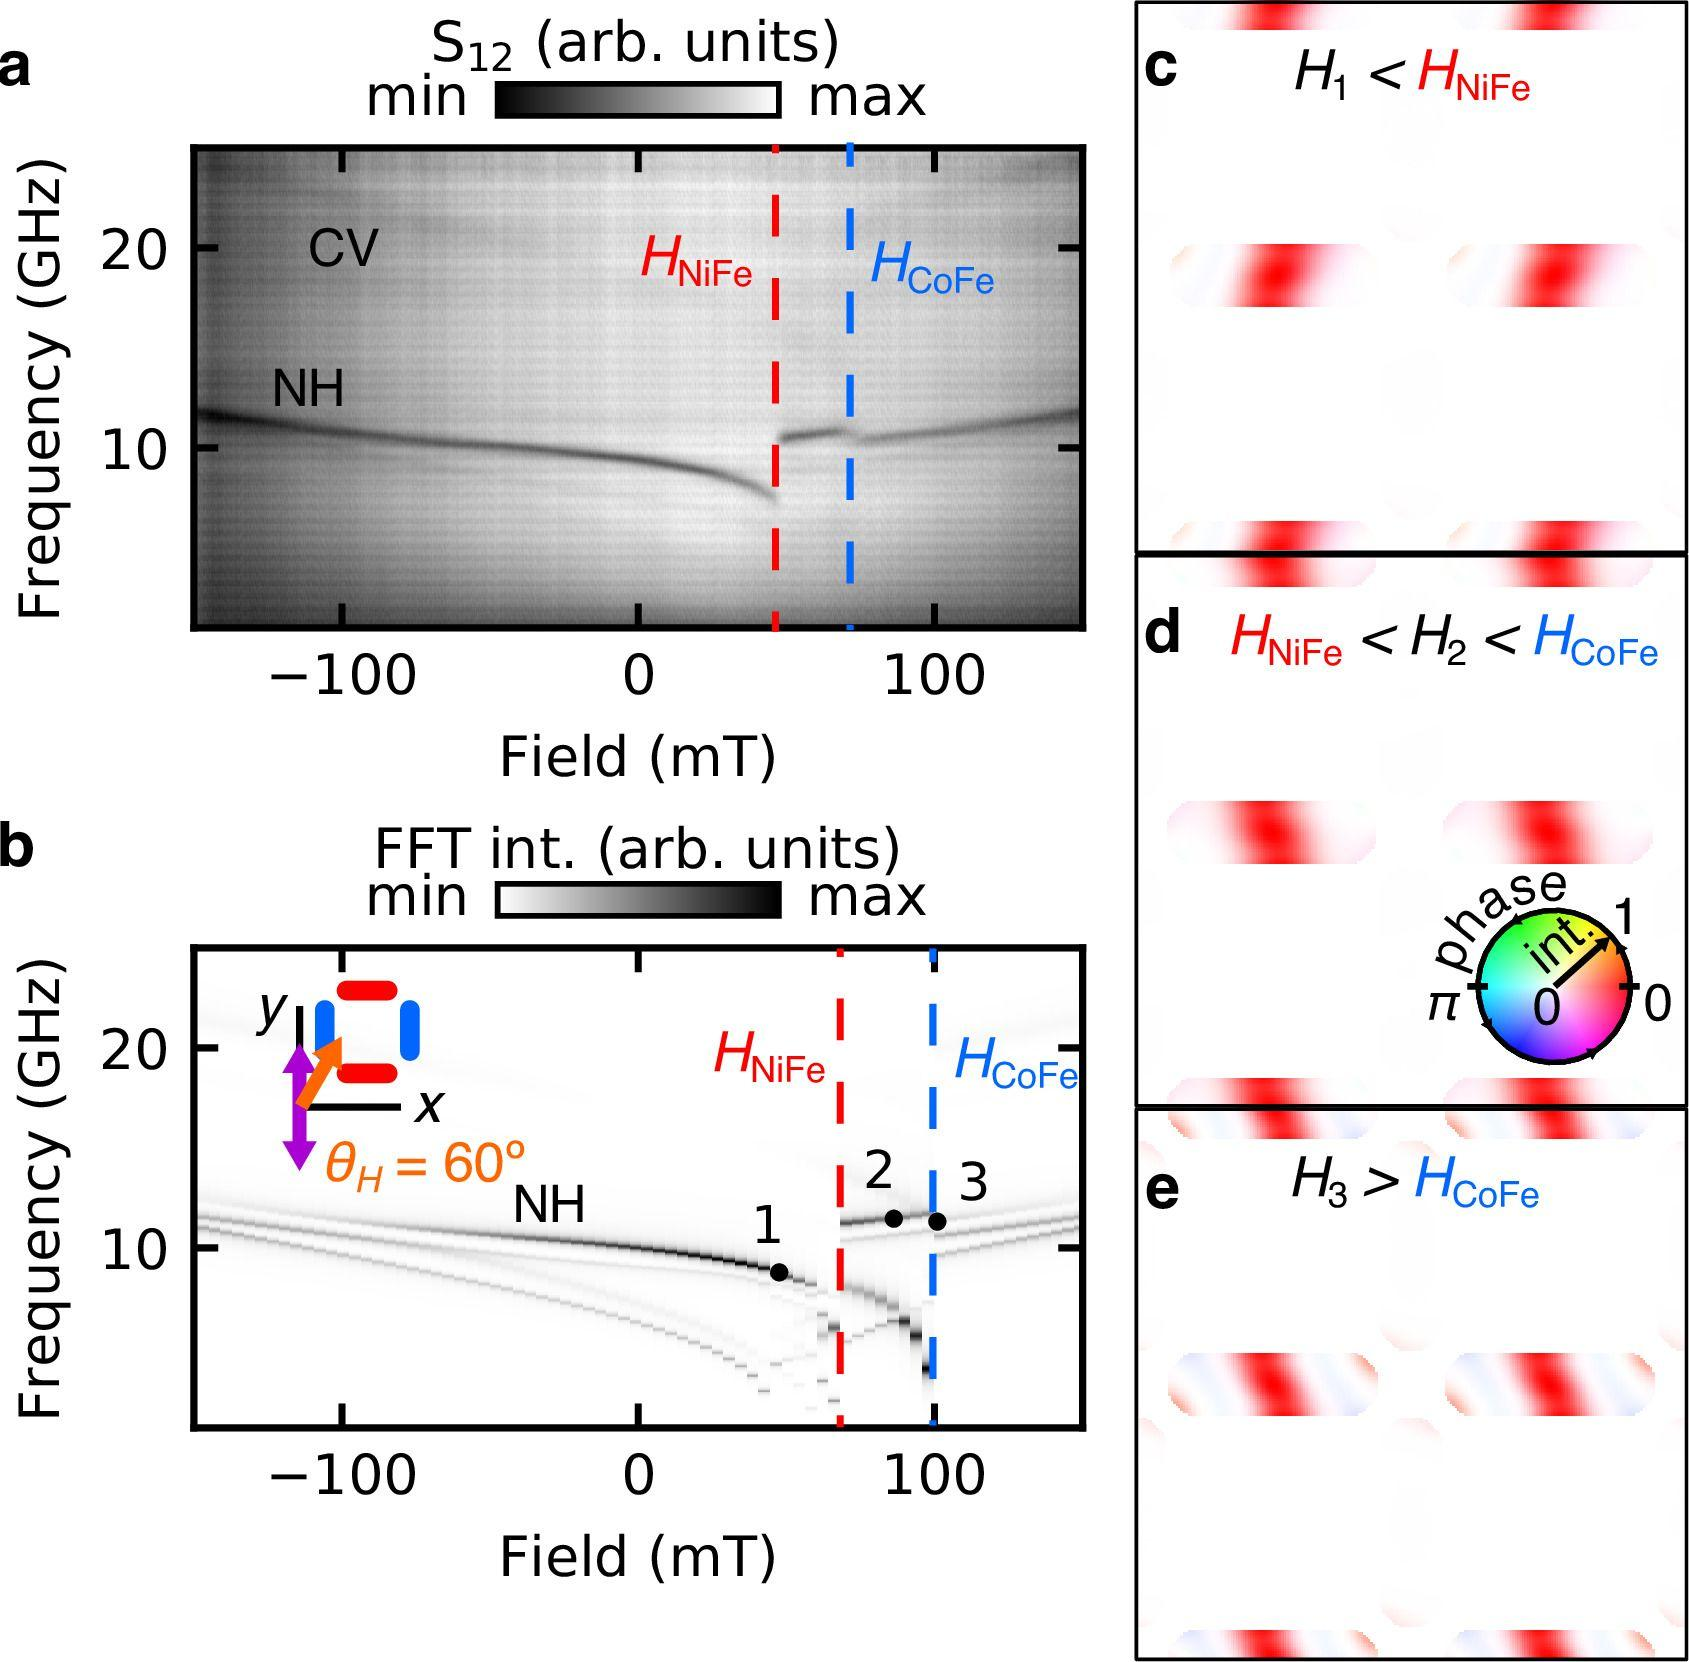Based on panels c, d, and e, what can be inferred about the relationship between \( H_1 \), \( H_2 \), and \( H_3 \) in relation to \( H_{NiFe} \) and \( H_{CoFe} \)? A. \( H_1 > H_{NiFe} \) and \( H_3 > H_{CoFe} \) B. \( H_1 < H_{NiFe} \) and \( H_3 < H_{CoFe} \) C. \( H_1 < H_{NiFe} \) and \( H_3 > H_{CoFe} \) D. \( H_2 < H_{NiFe} \) and \( H_3 < H_{CoFe} \) Upon reviewing the data from panels c, d, and e, it becomes clear that the magnetic field strengths labeled as \( H_1 \), \( H_2 \), and \( H_3 \) have distinct relationships with the thresholds identified at \( H_{NiFe} \) and \( H_{CoFe} \). Specifically, panel c indicates that \( H_1 \) is lower in magnitude compared to the threshold at \( H_{NiFe} \), suggesting that \( H_1 \) is inadequate to reach this field strength. Panel d reveals that the field strength \( H_2 \) falls between those defined by \( H_{NiFe} \) and \( H_{CoFe} \), denoting its intermediate value. Finally, panel e showcases that \( H_3 \) exceeds the threshold value set by \( H_{CoFe} \), indicating a superior field strength. Therefore, the correct relational inference is that \( H_1 \) is less than \( H_{NiFe} \) while \( H_3 \) exceeds \( H_{CoFe} \), making the correct answer: C. 